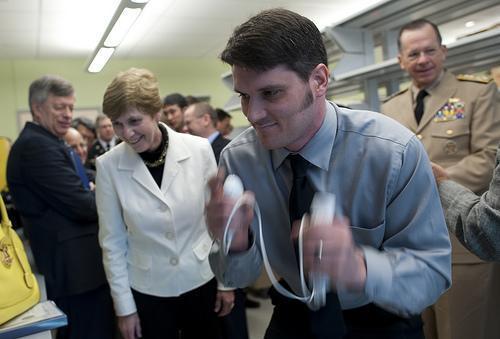How many women are in the picture?
Give a very brief answer. 1. How many old men are leaning?
Give a very brief answer. 1. How many men are wearing brown uniform?
Give a very brief answer. 1. How many women have a white jacket?
Give a very brief answer. 1. 